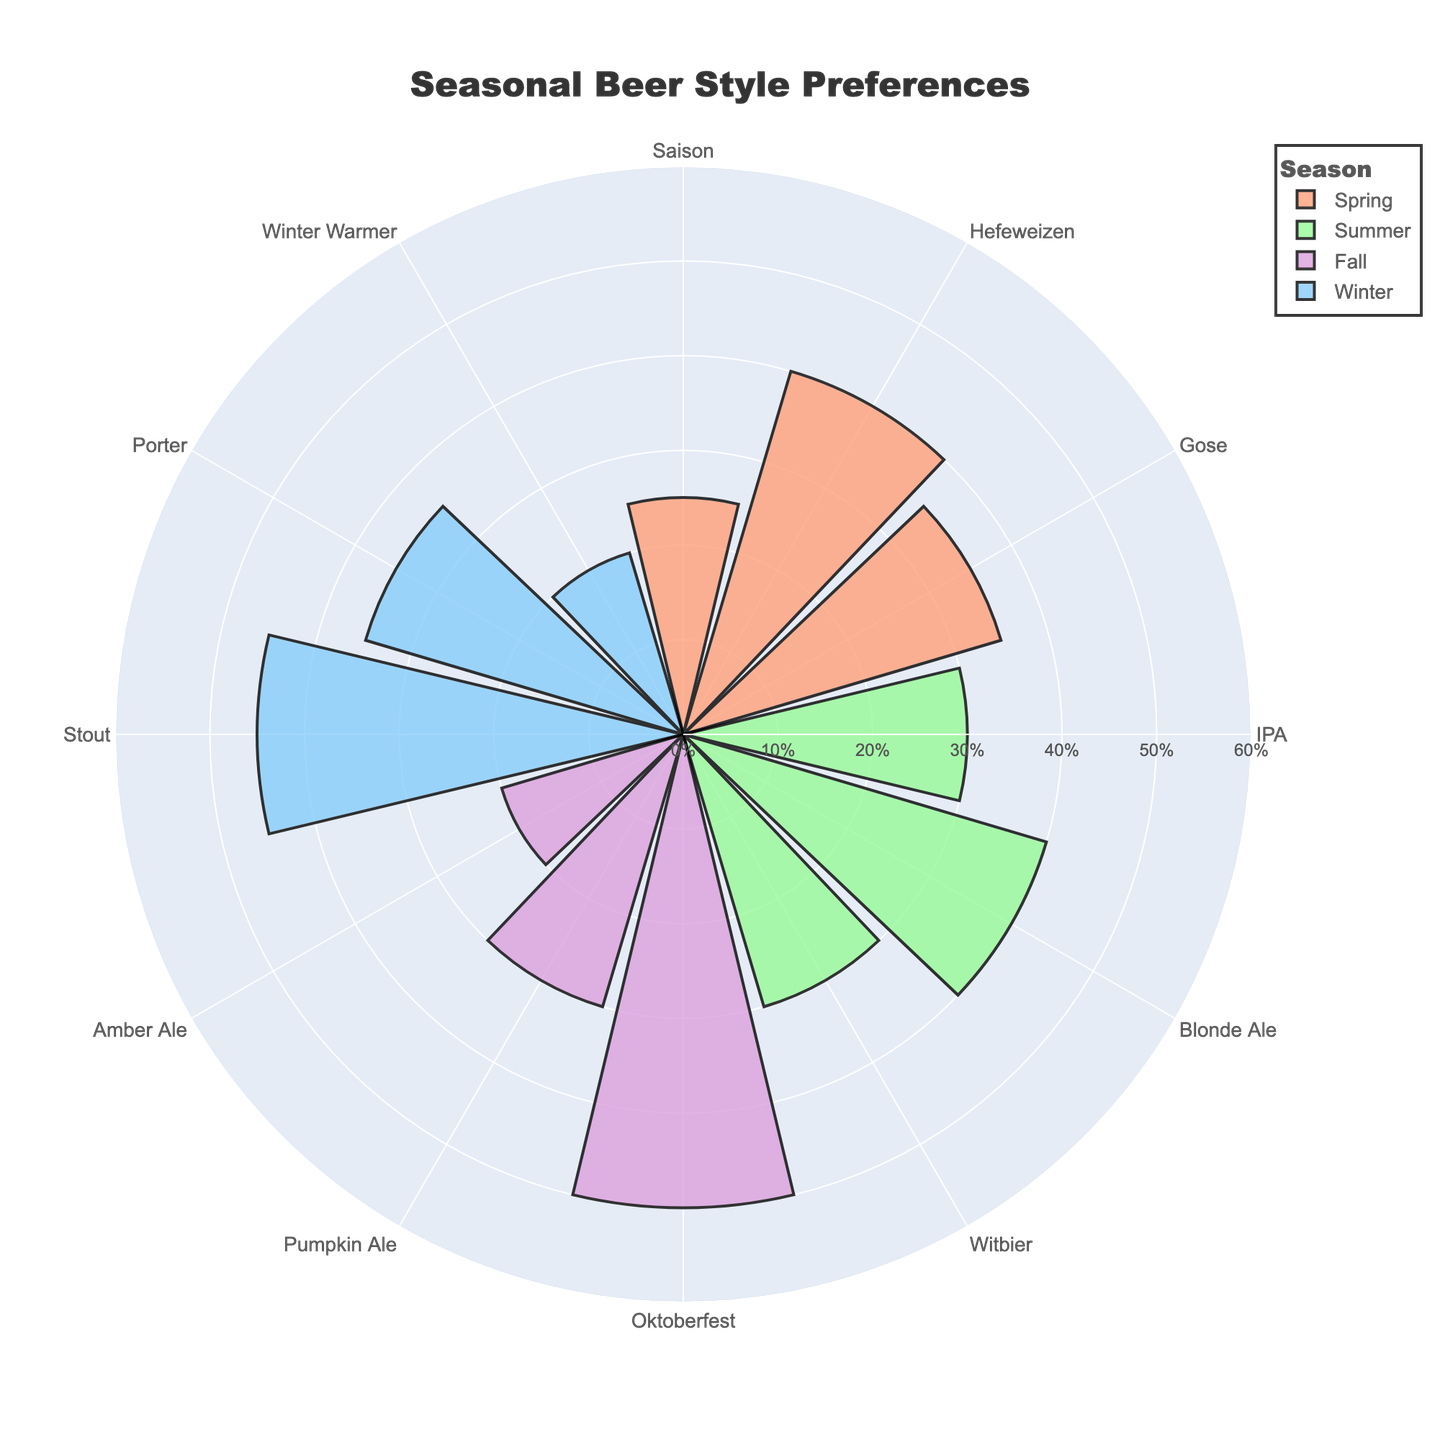What is the title of the chart? The title of the chart is usually displayed prominently at the top of the figure.
Answer: Seasonal Beer Style Preferences Which beer style has the highest percentage in the Fall season? In the Fall season section of the chart, look for the beer style with the highest value on the radial axis.
Answer: Oktoberfest Compare the preference percentage of Hefeweizen in Spring to Blonde Ale in Summer. Which one is higher? Identify the percentages of Hefeweizen in Spring and Blonde Ale in Summer from their locations on the chart and compare the two values.
Answer: Blonde Ale What is the combined percentage of all beer styles preferred during Winter? Sum the percentages of Stout, Porter, and Winter Warmer in the Winter season on the chart.
Answer: 100% Which season has the most evenly distributed beer preferences? Observe each season's chart section and check how close the percentages of the beer styles are to each other. The closest percentages indicate the most even distribution.
Answer: Winter How many beer styles are displayed for each season? Count the different beer styles listed under each season on the chart.
Answer: 3 What is the second most preferred beer style in Summer? Examine the Summer section of the chart and identify the style with the second-highest percentage.
Answer: IPA Compare the highest beer preference percentage in Spring with that in Winter. Which is higher? Identify the highest percentages in both Spring and Winter and then compare them.
Answer: Spring Which season has the highest preference for a single beer style? Identify the beer style with the highest percentage overall and note its season from the chart.
Answer: Fall What percentage of choices does Gose account for in Spring? Look for the Gose beer style in the Spring section and note the percentage given.
Answer: 35% 